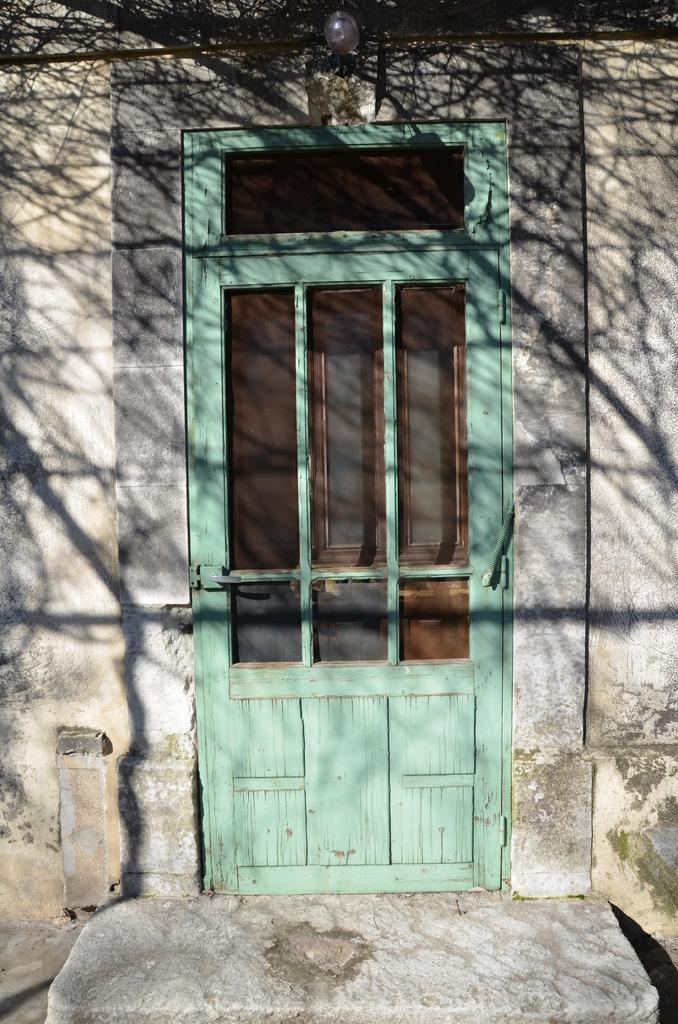What is one of the main architectural features in the image? There is a door in the image. Can you describe the lighting conditions in the image? There is light in the image. How are the walls depicted in the image? There are walls truncated towards the right and left of the image. What type of plate is being used for amusement in the image? There is no plate or amusement activity present in the image. 